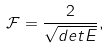Convert formula to latex. <formula><loc_0><loc_0><loc_500><loc_500>\mathcal { F } = \frac { 2 } { \sqrt { d e t { E } } } ,</formula> 